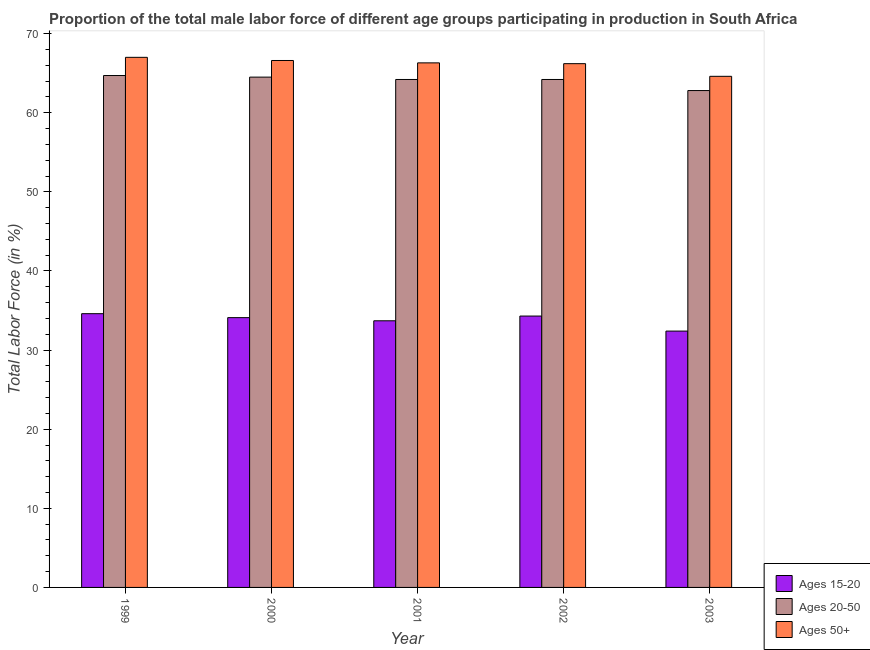How many groups of bars are there?
Offer a terse response. 5. Are the number of bars per tick equal to the number of legend labels?
Keep it short and to the point. Yes. How many bars are there on the 3rd tick from the left?
Ensure brevity in your answer.  3. What is the percentage of male labor force within the age group 15-20 in 1999?
Provide a succinct answer. 34.6. Across all years, what is the maximum percentage of male labor force within the age group 20-50?
Give a very brief answer. 64.7. Across all years, what is the minimum percentage of male labor force within the age group 20-50?
Offer a terse response. 62.8. What is the total percentage of male labor force above age 50 in the graph?
Offer a very short reply. 330.7. What is the difference between the percentage of male labor force within the age group 15-20 in 1999 and that in 2001?
Provide a succinct answer. 0.9. What is the difference between the percentage of male labor force within the age group 20-50 in 2000 and the percentage of male labor force within the age group 15-20 in 1999?
Provide a short and direct response. -0.2. What is the average percentage of male labor force above age 50 per year?
Provide a short and direct response. 66.14. In the year 2001, what is the difference between the percentage of male labor force above age 50 and percentage of male labor force within the age group 15-20?
Make the answer very short. 0. In how many years, is the percentage of male labor force within the age group 20-50 greater than 26 %?
Provide a succinct answer. 5. What is the ratio of the percentage of male labor force above age 50 in 2000 to that in 2003?
Your answer should be compact. 1.03. Is the percentage of male labor force within the age group 15-20 in 2000 less than that in 2001?
Your answer should be compact. No. What is the difference between the highest and the second highest percentage of male labor force within the age group 15-20?
Offer a terse response. 0.3. What is the difference between the highest and the lowest percentage of male labor force within the age group 20-50?
Make the answer very short. 1.9. Is the sum of the percentage of male labor force above age 50 in 2001 and 2002 greater than the maximum percentage of male labor force within the age group 20-50 across all years?
Give a very brief answer. Yes. What does the 3rd bar from the left in 2002 represents?
Your answer should be compact. Ages 50+. What does the 3rd bar from the right in 2000 represents?
Keep it short and to the point. Ages 15-20. How many bars are there?
Your answer should be very brief. 15. Are all the bars in the graph horizontal?
Offer a very short reply. No. What is the difference between two consecutive major ticks on the Y-axis?
Ensure brevity in your answer.  10. Are the values on the major ticks of Y-axis written in scientific E-notation?
Make the answer very short. No. How many legend labels are there?
Ensure brevity in your answer.  3. What is the title of the graph?
Give a very brief answer. Proportion of the total male labor force of different age groups participating in production in South Africa. Does "Taxes on income" appear as one of the legend labels in the graph?
Your answer should be very brief. No. What is the label or title of the X-axis?
Make the answer very short. Year. What is the label or title of the Y-axis?
Offer a terse response. Total Labor Force (in %). What is the Total Labor Force (in %) of Ages 15-20 in 1999?
Your answer should be compact. 34.6. What is the Total Labor Force (in %) of Ages 20-50 in 1999?
Offer a terse response. 64.7. What is the Total Labor Force (in %) of Ages 15-20 in 2000?
Keep it short and to the point. 34.1. What is the Total Labor Force (in %) of Ages 20-50 in 2000?
Offer a very short reply. 64.5. What is the Total Labor Force (in %) in Ages 50+ in 2000?
Offer a very short reply. 66.6. What is the Total Labor Force (in %) of Ages 15-20 in 2001?
Provide a short and direct response. 33.7. What is the Total Labor Force (in %) in Ages 20-50 in 2001?
Your response must be concise. 64.2. What is the Total Labor Force (in %) in Ages 50+ in 2001?
Provide a short and direct response. 66.3. What is the Total Labor Force (in %) of Ages 15-20 in 2002?
Your response must be concise. 34.3. What is the Total Labor Force (in %) of Ages 20-50 in 2002?
Provide a succinct answer. 64.2. What is the Total Labor Force (in %) in Ages 50+ in 2002?
Offer a terse response. 66.2. What is the Total Labor Force (in %) of Ages 15-20 in 2003?
Ensure brevity in your answer.  32.4. What is the Total Labor Force (in %) of Ages 20-50 in 2003?
Provide a short and direct response. 62.8. What is the Total Labor Force (in %) of Ages 50+ in 2003?
Provide a succinct answer. 64.6. Across all years, what is the maximum Total Labor Force (in %) of Ages 15-20?
Provide a short and direct response. 34.6. Across all years, what is the maximum Total Labor Force (in %) of Ages 20-50?
Offer a very short reply. 64.7. Across all years, what is the minimum Total Labor Force (in %) of Ages 15-20?
Ensure brevity in your answer.  32.4. Across all years, what is the minimum Total Labor Force (in %) of Ages 20-50?
Your answer should be very brief. 62.8. Across all years, what is the minimum Total Labor Force (in %) of Ages 50+?
Provide a short and direct response. 64.6. What is the total Total Labor Force (in %) of Ages 15-20 in the graph?
Provide a short and direct response. 169.1. What is the total Total Labor Force (in %) of Ages 20-50 in the graph?
Ensure brevity in your answer.  320.4. What is the total Total Labor Force (in %) in Ages 50+ in the graph?
Your answer should be very brief. 330.7. What is the difference between the Total Labor Force (in %) of Ages 15-20 in 1999 and that in 2000?
Your answer should be compact. 0.5. What is the difference between the Total Labor Force (in %) in Ages 50+ in 1999 and that in 2000?
Offer a very short reply. 0.4. What is the difference between the Total Labor Force (in %) of Ages 15-20 in 1999 and that in 2001?
Provide a succinct answer. 0.9. What is the difference between the Total Labor Force (in %) in Ages 20-50 in 1999 and that in 2001?
Your answer should be compact. 0.5. What is the difference between the Total Labor Force (in %) in Ages 50+ in 1999 and that in 2001?
Ensure brevity in your answer.  0.7. What is the difference between the Total Labor Force (in %) of Ages 15-20 in 1999 and that in 2002?
Make the answer very short. 0.3. What is the difference between the Total Labor Force (in %) of Ages 20-50 in 1999 and that in 2002?
Make the answer very short. 0.5. What is the difference between the Total Labor Force (in %) in Ages 50+ in 1999 and that in 2002?
Make the answer very short. 0.8. What is the difference between the Total Labor Force (in %) of Ages 50+ in 1999 and that in 2003?
Your answer should be compact. 2.4. What is the difference between the Total Labor Force (in %) in Ages 20-50 in 2000 and that in 2001?
Offer a terse response. 0.3. What is the difference between the Total Labor Force (in %) in Ages 20-50 in 2000 and that in 2002?
Provide a short and direct response. 0.3. What is the difference between the Total Labor Force (in %) of Ages 20-50 in 2000 and that in 2003?
Your answer should be compact. 1.7. What is the difference between the Total Labor Force (in %) of Ages 50+ in 2000 and that in 2003?
Provide a short and direct response. 2. What is the difference between the Total Labor Force (in %) in Ages 15-20 in 2001 and that in 2002?
Your response must be concise. -0.6. What is the difference between the Total Labor Force (in %) in Ages 20-50 in 2001 and that in 2002?
Keep it short and to the point. 0. What is the difference between the Total Labor Force (in %) of Ages 20-50 in 2001 and that in 2003?
Ensure brevity in your answer.  1.4. What is the difference between the Total Labor Force (in %) of Ages 15-20 in 2002 and that in 2003?
Keep it short and to the point. 1.9. What is the difference between the Total Labor Force (in %) of Ages 50+ in 2002 and that in 2003?
Your response must be concise. 1.6. What is the difference between the Total Labor Force (in %) of Ages 15-20 in 1999 and the Total Labor Force (in %) of Ages 20-50 in 2000?
Your response must be concise. -29.9. What is the difference between the Total Labor Force (in %) of Ages 15-20 in 1999 and the Total Labor Force (in %) of Ages 50+ in 2000?
Provide a short and direct response. -32. What is the difference between the Total Labor Force (in %) of Ages 15-20 in 1999 and the Total Labor Force (in %) of Ages 20-50 in 2001?
Keep it short and to the point. -29.6. What is the difference between the Total Labor Force (in %) in Ages 15-20 in 1999 and the Total Labor Force (in %) in Ages 50+ in 2001?
Make the answer very short. -31.7. What is the difference between the Total Labor Force (in %) of Ages 20-50 in 1999 and the Total Labor Force (in %) of Ages 50+ in 2001?
Ensure brevity in your answer.  -1.6. What is the difference between the Total Labor Force (in %) of Ages 15-20 in 1999 and the Total Labor Force (in %) of Ages 20-50 in 2002?
Your answer should be very brief. -29.6. What is the difference between the Total Labor Force (in %) of Ages 15-20 in 1999 and the Total Labor Force (in %) of Ages 50+ in 2002?
Your answer should be compact. -31.6. What is the difference between the Total Labor Force (in %) in Ages 15-20 in 1999 and the Total Labor Force (in %) in Ages 20-50 in 2003?
Offer a very short reply. -28.2. What is the difference between the Total Labor Force (in %) in Ages 15-20 in 2000 and the Total Labor Force (in %) in Ages 20-50 in 2001?
Provide a short and direct response. -30.1. What is the difference between the Total Labor Force (in %) in Ages 15-20 in 2000 and the Total Labor Force (in %) in Ages 50+ in 2001?
Offer a very short reply. -32.2. What is the difference between the Total Labor Force (in %) in Ages 20-50 in 2000 and the Total Labor Force (in %) in Ages 50+ in 2001?
Give a very brief answer. -1.8. What is the difference between the Total Labor Force (in %) in Ages 15-20 in 2000 and the Total Labor Force (in %) in Ages 20-50 in 2002?
Keep it short and to the point. -30.1. What is the difference between the Total Labor Force (in %) of Ages 15-20 in 2000 and the Total Labor Force (in %) of Ages 50+ in 2002?
Your answer should be compact. -32.1. What is the difference between the Total Labor Force (in %) of Ages 15-20 in 2000 and the Total Labor Force (in %) of Ages 20-50 in 2003?
Provide a succinct answer. -28.7. What is the difference between the Total Labor Force (in %) of Ages 15-20 in 2000 and the Total Labor Force (in %) of Ages 50+ in 2003?
Ensure brevity in your answer.  -30.5. What is the difference between the Total Labor Force (in %) in Ages 15-20 in 2001 and the Total Labor Force (in %) in Ages 20-50 in 2002?
Give a very brief answer. -30.5. What is the difference between the Total Labor Force (in %) of Ages 15-20 in 2001 and the Total Labor Force (in %) of Ages 50+ in 2002?
Provide a short and direct response. -32.5. What is the difference between the Total Labor Force (in %) in Ages 15-20 in 2001 and the Total Labor Force (in %) in Ages 20-50 in 2003?
Your answer should be very brief. -29.1. What is the difference between the Total Labor Force (in %) in Ages 15-20 in 2001 and the Total Labor Force (in %) in Ages 50+ in 2003?
Your answer should be very brief. -30.9. What is the difference between the Total Labor Force (in %) of Ages 20-50 in 2001 and the Total Labor Force (in %) of Ages 50+ in 2003?
Your answer should be very brief. -0.4. What is the difference between the Total Labor Force (in %) of Ages 15-20 in 2002 and the Total Labor Force (in %) of Ages 20-50 in 2003?
Keep it short and to the point. -28.5. What is the difference between the Total Labor Force (in %) of Ages 15-20 in 2002 and the Total Labor Force (in %) of Ages 50+ in 2003?
Your answer should be compact. -30.3. What is the difference between the Total Labor Force (in %) of Ages 20-50 in 2002 and the Total Labor Force (in %) of Ages 50+ in 2003?
Ensure brevity in your answer.  -0.4. What is the average Total Labor Force (in %) of Ages 15-20 per year?
Your response must be concise. 33.82. What is the average Total Labor Force (in %) in Ages 20-50 per year?
Make the answer very short. 64.08. What is the average Total Labor Force (in %) of Ages 50+ per year?
Give a very brief answer. 66.14. In the year 1999, what is the difference between the Total Labor Force (in %) in Ages 15-20 and Total Labor Force (in %) in Ages 20-50?
Your answer should be very brief. -30.1. In the year 1999, what is the difference between the Total Labor Force (in %) of Ages 15-20 and Total Labor Force (in %) of Ages 50+?
Keep it short and to the point. -32.4. In the year 2000, what is the difference between the Total Labor Force (in %) in Ages 15-20 and Total Labor Force (in %) in Ages 20-50?
Provide a succinct answer. -30.4. In the year 2000, what is the difference between the Total Labor Force (in %) in Ages 15-20 and Total Labor Force (in %) in Ages 50+?
Offer a very short reply. -32.5. In the year 2001, what is the difference between the Total Labor Force (in %) of Ages 15-20 and Total Labor Force (in %) of Ages 20-50?
Your answer should be very brief. -30.5. In the year 2001, what is the difference between the Total Labor Force (in %) of Ages 15-20 and Total Labor Force (in %) of Ages 50+?
Provide a succinct answer. -32.6. In the year 2001, what is the difference between the Total Labor Force (in %) in Ages 20-50 and Total Labor Force (in %) in Ages 50+?
Your response must be concise. -2.1. In the year 2002, what is the difference between the Total Labor Force (in %) in Ages 15-20 and Total Labor Force (in %) in Ages 20-50?
Offer a terse response. -29.9. In the year 2002, what is the difference between the Total Labor Force (in %) in Ages 15-20 and Total Labor Force (in %) in Ages 50+?
Give a very brief answer. -31.9. In the year 2003, what is the difference between the Total Labor Force (in %) in Ages 15-20 and Total Labor Force (in %) in Ages 20-50?
Offer a terse response. -30.4. In the year 2003, what is the difference between the Total Labor Force (in %) of Ages 15-20 and Total Labor Force (in %) of Ages 50+?
Offer a very short reply. -32.2. What is the ratio of the Total Labor Force (in %) of Ages 15-20 in 1999 to that in 2000?
Your response must be concise. 1.01. What is the ratio of the Total Labor Force (in %) in Ages 15-20 in 1999 to that in 2001?
Offer a terse response. 1.03. What is the ratio of the Total Labor Force (in %) of Ages 20-50 in 1999 to that in 2001?
Make the answer very short. 1.01. What is the ratio of the Total Labor Force (in %) of Ages 50+ in 1999 to that in 2001?
Ensure brevity in your answer.  1.01. What is the ratio of the Total Labor Force (in %) of Ages 15-20 in 1999 to that in 2002?
Make the answer very short. 1.01. What is the ratio of the Total Labor Force (in %) in Ages 20-50 in 1999 to that in 2002?
Give a very brief answer. 1.01. What is the ratio of the Total Labor Force (in %) of Ages 50+ in 1999 to that in 2002?
Provide a succinct answer. 1.01. What is the ratio of the Total Labor Force (in %) in Ages 15-20 in 1999 to that in 2003?
Provide a short and direct response. 1.07. What is the ratio of the Total Labor Force (in %) of Ages 20-50 in 1999 to that in 2003?
Give a very brief answer. 1.03. What is the ratio of the Total Labor Force (in %) of Ages 50+ in 1999 to that in 2003?
Keep it short and to the point. 1.04. What is the ratio of the Total Labor Force (in %) of Ages 15-20 in 2000 to that in 2001?
Make the answer very short. 1.01. What is the ratio of the Total Labor Force (in %) in Ages 50+ in 2000 to that in 2002?
Provide a short and direct response. 1.01. What is the ratio of the Total Labor Force (in %) in Ages 15-20 in 2000 to that in 2003?
Provide a short and direct response. 1.05. What is the ratio of the Total Labor Force (in %) in Ages 20-50 in 2000 to that in 2003?
Offer a terse response. 1.03. What is the ratio of the Total Labor Force (in %) of Ages 50+ in 2000 to that in 2003?
Give a very brief answer. 1.03. What is the ratio of the Total Labor Force (in %) of Ages 15-20 in 2001 to that in 2002?
Provide a succinct answer. 0.98. What is the ratio of the Total Labor Force (in %) of Ages 50+ in 2001 to that in 2002?
Your response must be concise. 1. What is the ratio of the Total Labor Force (in %) of Ages 15-20 in 2001 to that in 2003?
Provide a succinct answer. 1.04. What is the ratio of the Total Labor Force (in %) of Ages 20-50 in 2001 to that in 2003?
Offer a terse response. 1.02. What is the ratio of the Total Labor Force (in %) in Ages 50+ in 2001 to that in 2003?
Provide a succinct answer. 1.03. What is the ratio of the Total Labor Force (in %) in Ages 15-20 in 2002 to that in 2003?
Your answer should be very brief. 1.06. What is the ratio of the Total Labor Force (in %) of Ages 20-50 in 2002 to that in 2003?
Keep it short and to the point. 1.02. What is the ratio of the Total Labor Force (in %) of Ages 50+ in 2002 to that in 2003?
Ensure brevity in your answer.  1.02. What is the difference between the highest and the second highest Total Labor Force (in %) of Ages 15-20?
Offer a terse response. 0.3. What is the difference between the highest and the second highest Total Labor Force (in %) of Ages 20-50?
Offer a very short reply. 0.2. What is the difference between the highest and the second highest Total Labor Force (in %) of Ages 50+?
Give a very brief answer. 0.4. What is the difference between the highest and the lowest Total Labor Force (in %) in Ages 15-20?
Your answer should be very brief. 2.2. What is the difference between the highest and the lowest Total Labor Force (in %) in Ages 20-50?
Offer a very short reply. 1.9. 